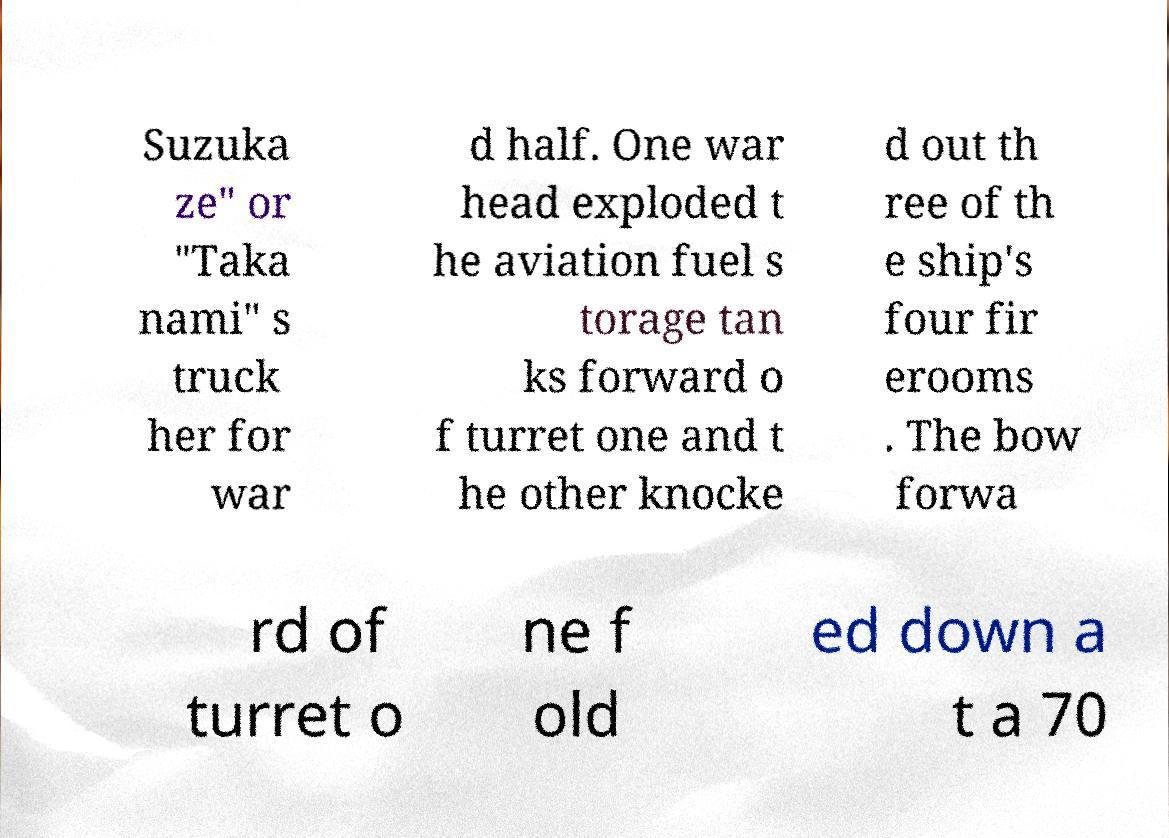I need the written content from this picture converted into text. Can you do that? Suzuka ze" or "Taka nami" s truck her for war d half. One war head exploded t he aviation fuel s torage tan ks forward o f turret one and t he other knocke d out th ree of th e ship's four fir erooms . The bow forwa rd of turret o ne f old ed down a t a 70 